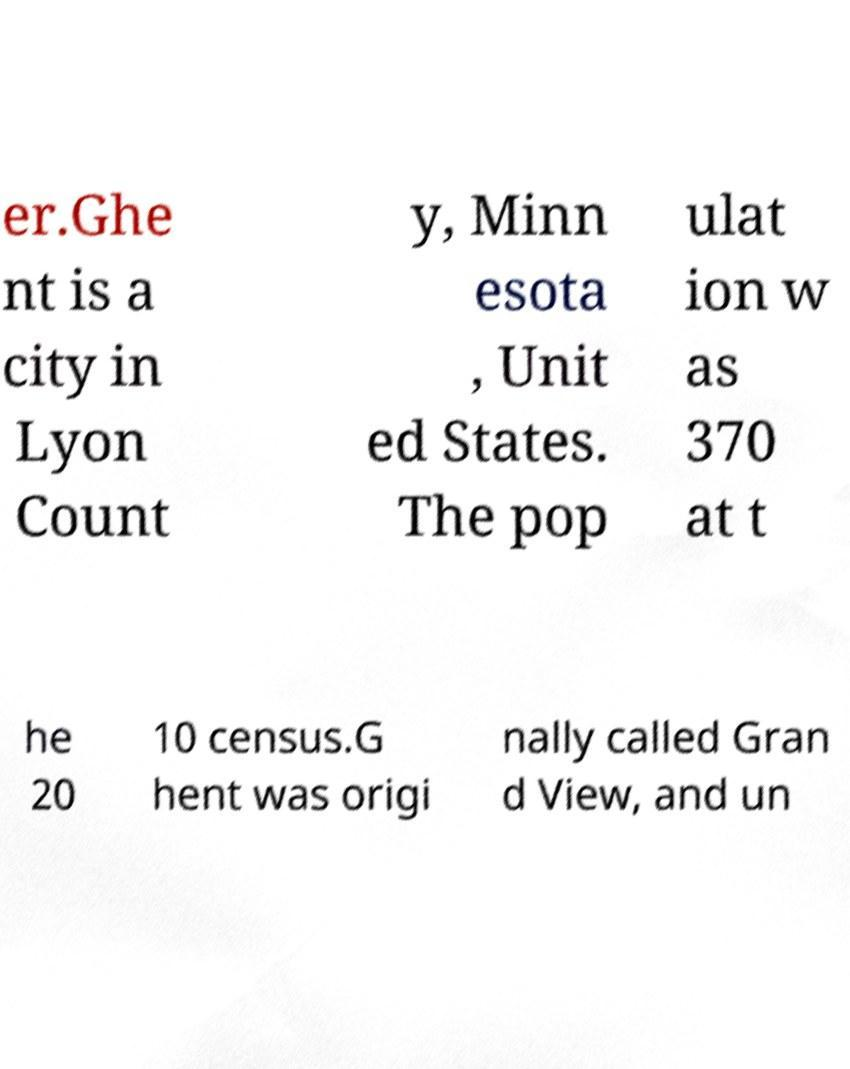For documentation purposes, I need the text within this image transcribed. Could you provide that? er.Ghe nt is a city in Lyon Count y, Minn esota , Unit ed States. The pop ulat ion w as 370 at t he 20 10 census.G hent was origi nally called Gran d View, and un 